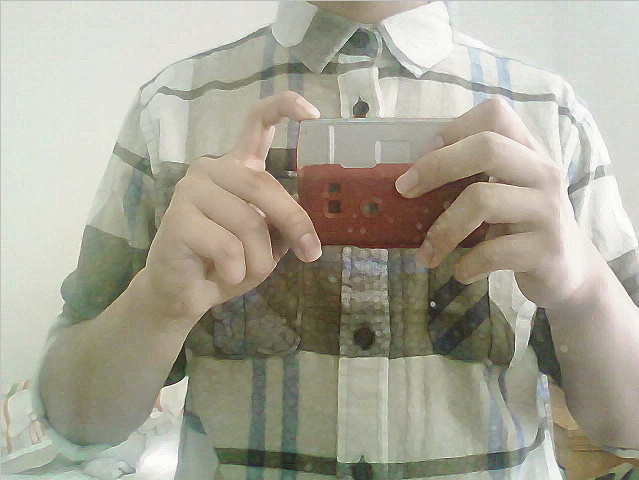Describe the objects in this image and their specific colors. I can see people in lightgray, darkgray, and gray tones and cell phone in lightgray, darkgray, maroon, and brown tones in this image. 